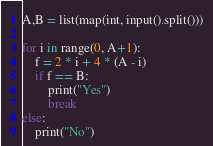<code> <loc_0><loc_0><loc_500><loc_500><_Python_>A,B = list(map(int, input().split()))

for i in range(0, A+1):
    f = 2 * i + 4 * (A - i)
    if f == B:
        print("Yes")
        break
else:
    print("No")</code> 